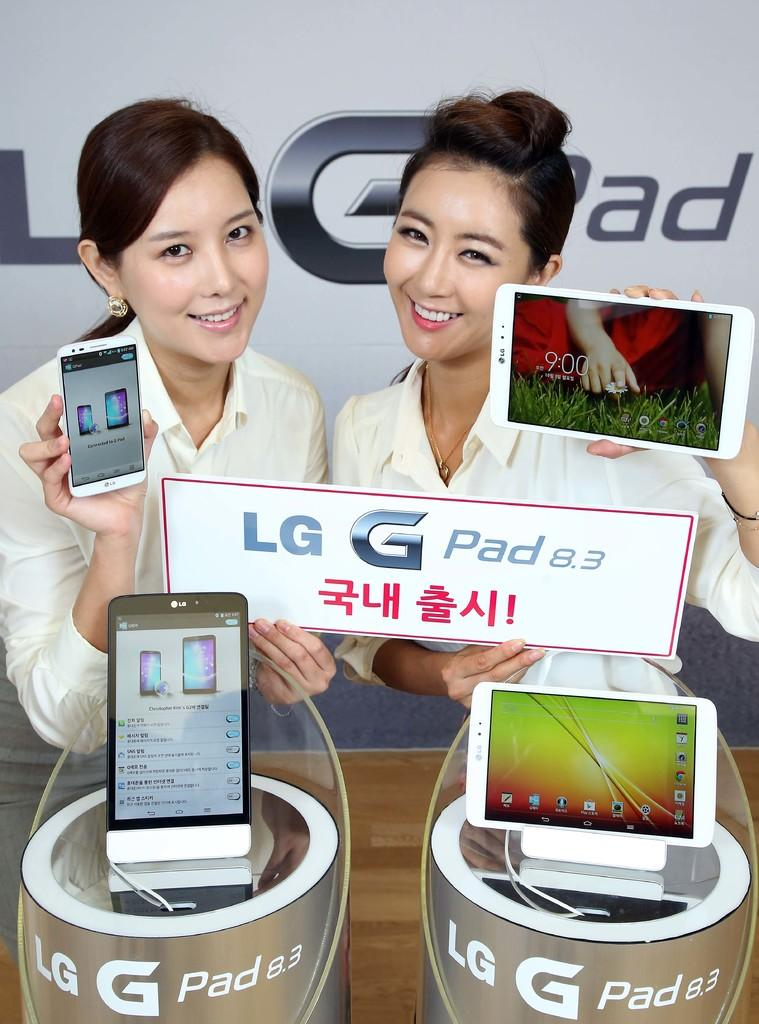Provide a one-sentence caption for the provided image. Two women holding different size devices as the hold a sign that reads LG G Pad 8.3. 